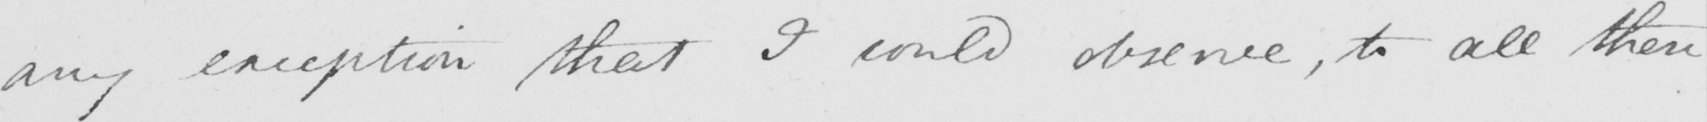Can you read and transcribe this handwriting? any exception that I could observe , to all these 